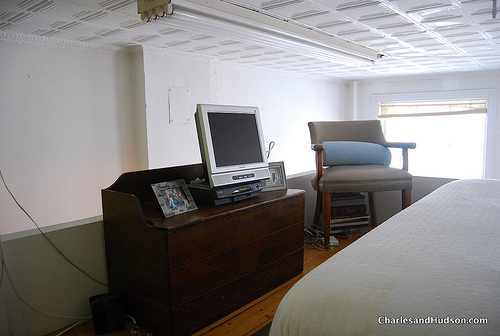Describe the style and color theme of the room based on what you can see. The room follows a minimalist style with a mostly neutral color scheme dominated by whites and grays, contributing to a calm and uncluttered environment. Are there any elements in the room that you think add a unique touch? The presence of a large gray chair adds a touch of sophistication, while the wooden dresser provides a classic, timeless look. 